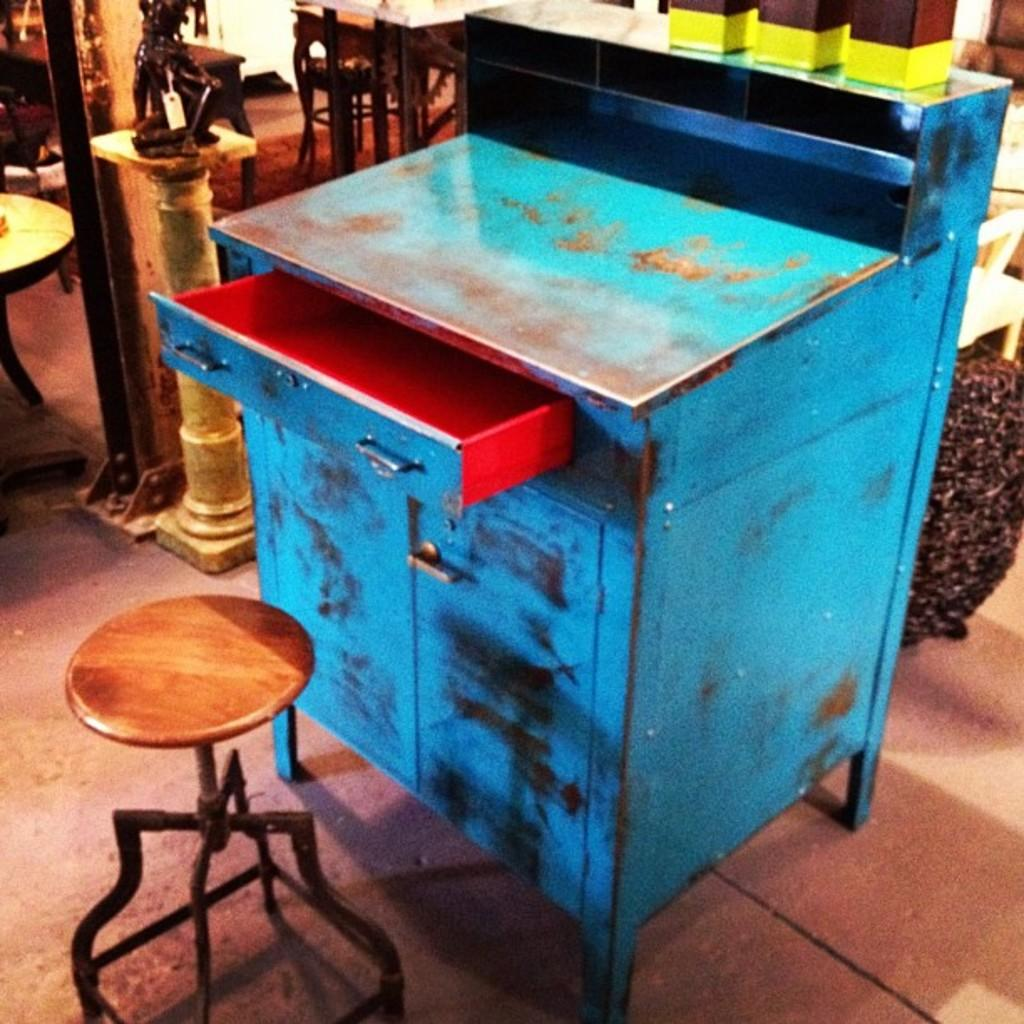What is the color of the drawer in the image? The drawer in the image is blue. What type of furniture is present in the image? There is a stool in the image. What can be seen in the background of the image? In the background of the image, there is a mini sculpture, a table, and additional objects. What type of chalk is being used to draw on the table in the image? There is no chalk or drawing on the table in the image. What is the tax rate for the items in the image? There is no information about tax rates in the image. 